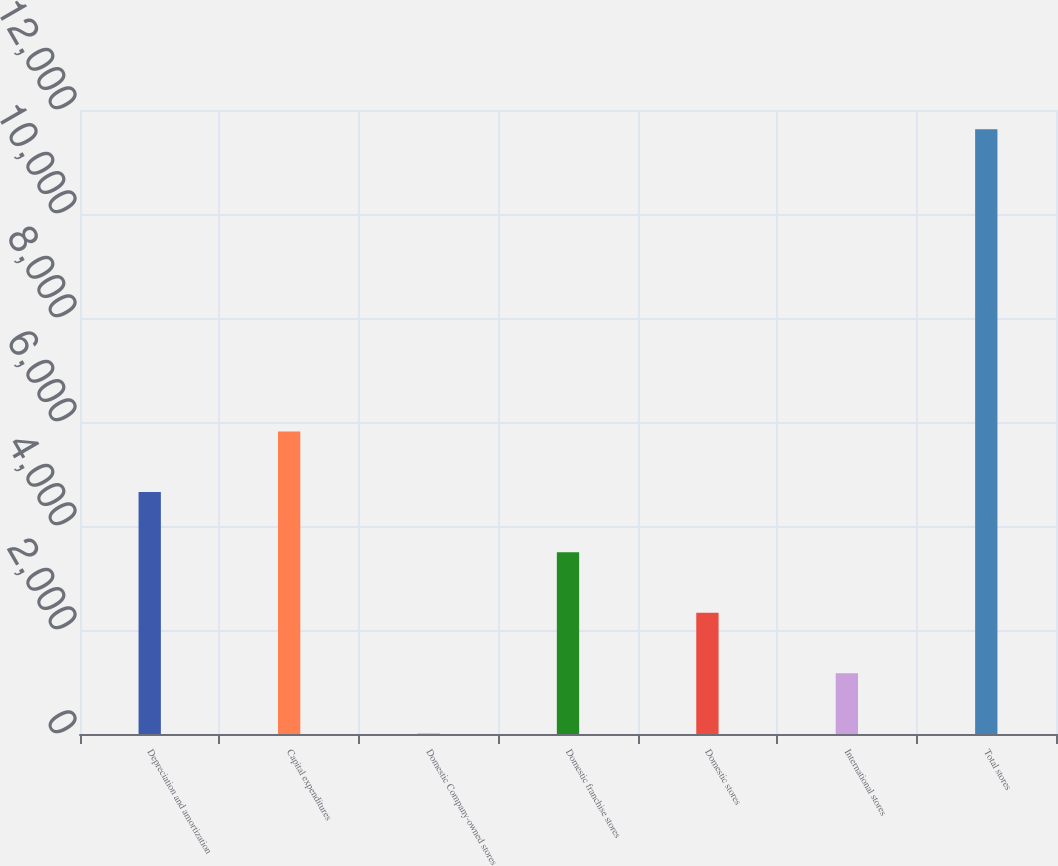Convert chart to OTSL. <chart><loc_0><loc_0><loc_500><loc_500><bar_chart><fcel>Depreciation and amortization<fcel>Capital expenditures<fcel>Domestic Company-owned stores<fcel>Domestic franchise stores<fcel>Domestic stores<fcel>International stores<fcel>Total stores<nl><fcel>4655.32<fcel>5817.6<fcel>6.2<fcel>3493.04<fcel>2330.76<fcel>1168.48<fcel>11629<nl></chart> 